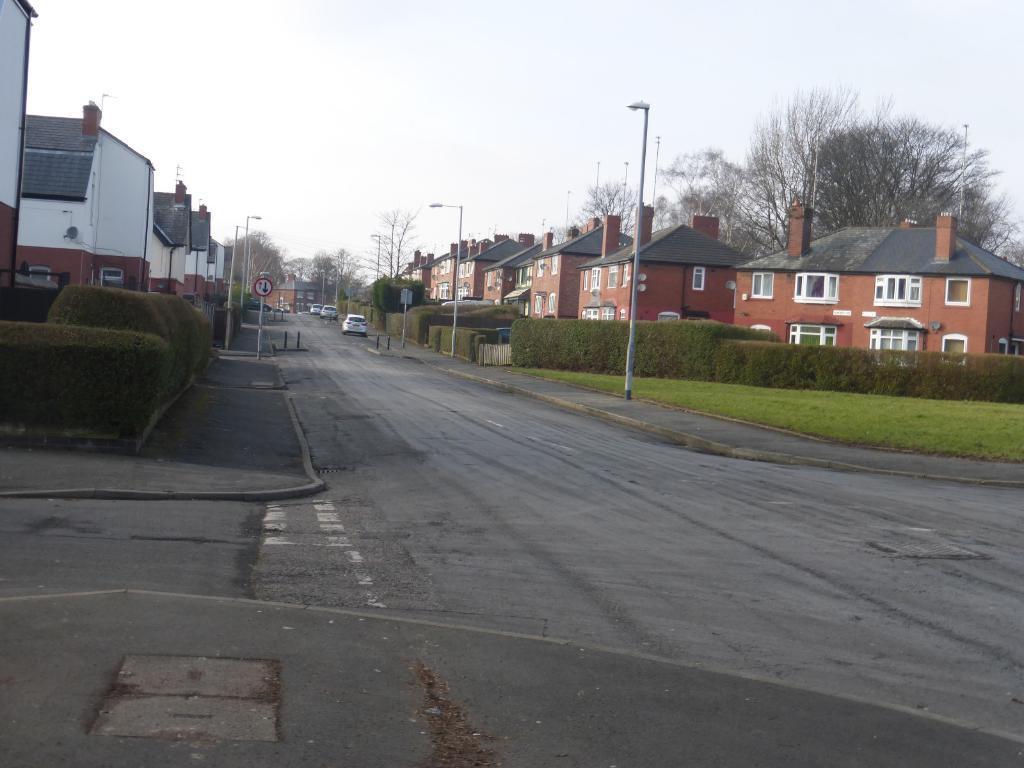Please provide a concise description of this image. In this picture I can see vehicles on the road, there are poles, lights, there is a signboard, there are houses, there are plants, trees, and in the background there is the sky. 